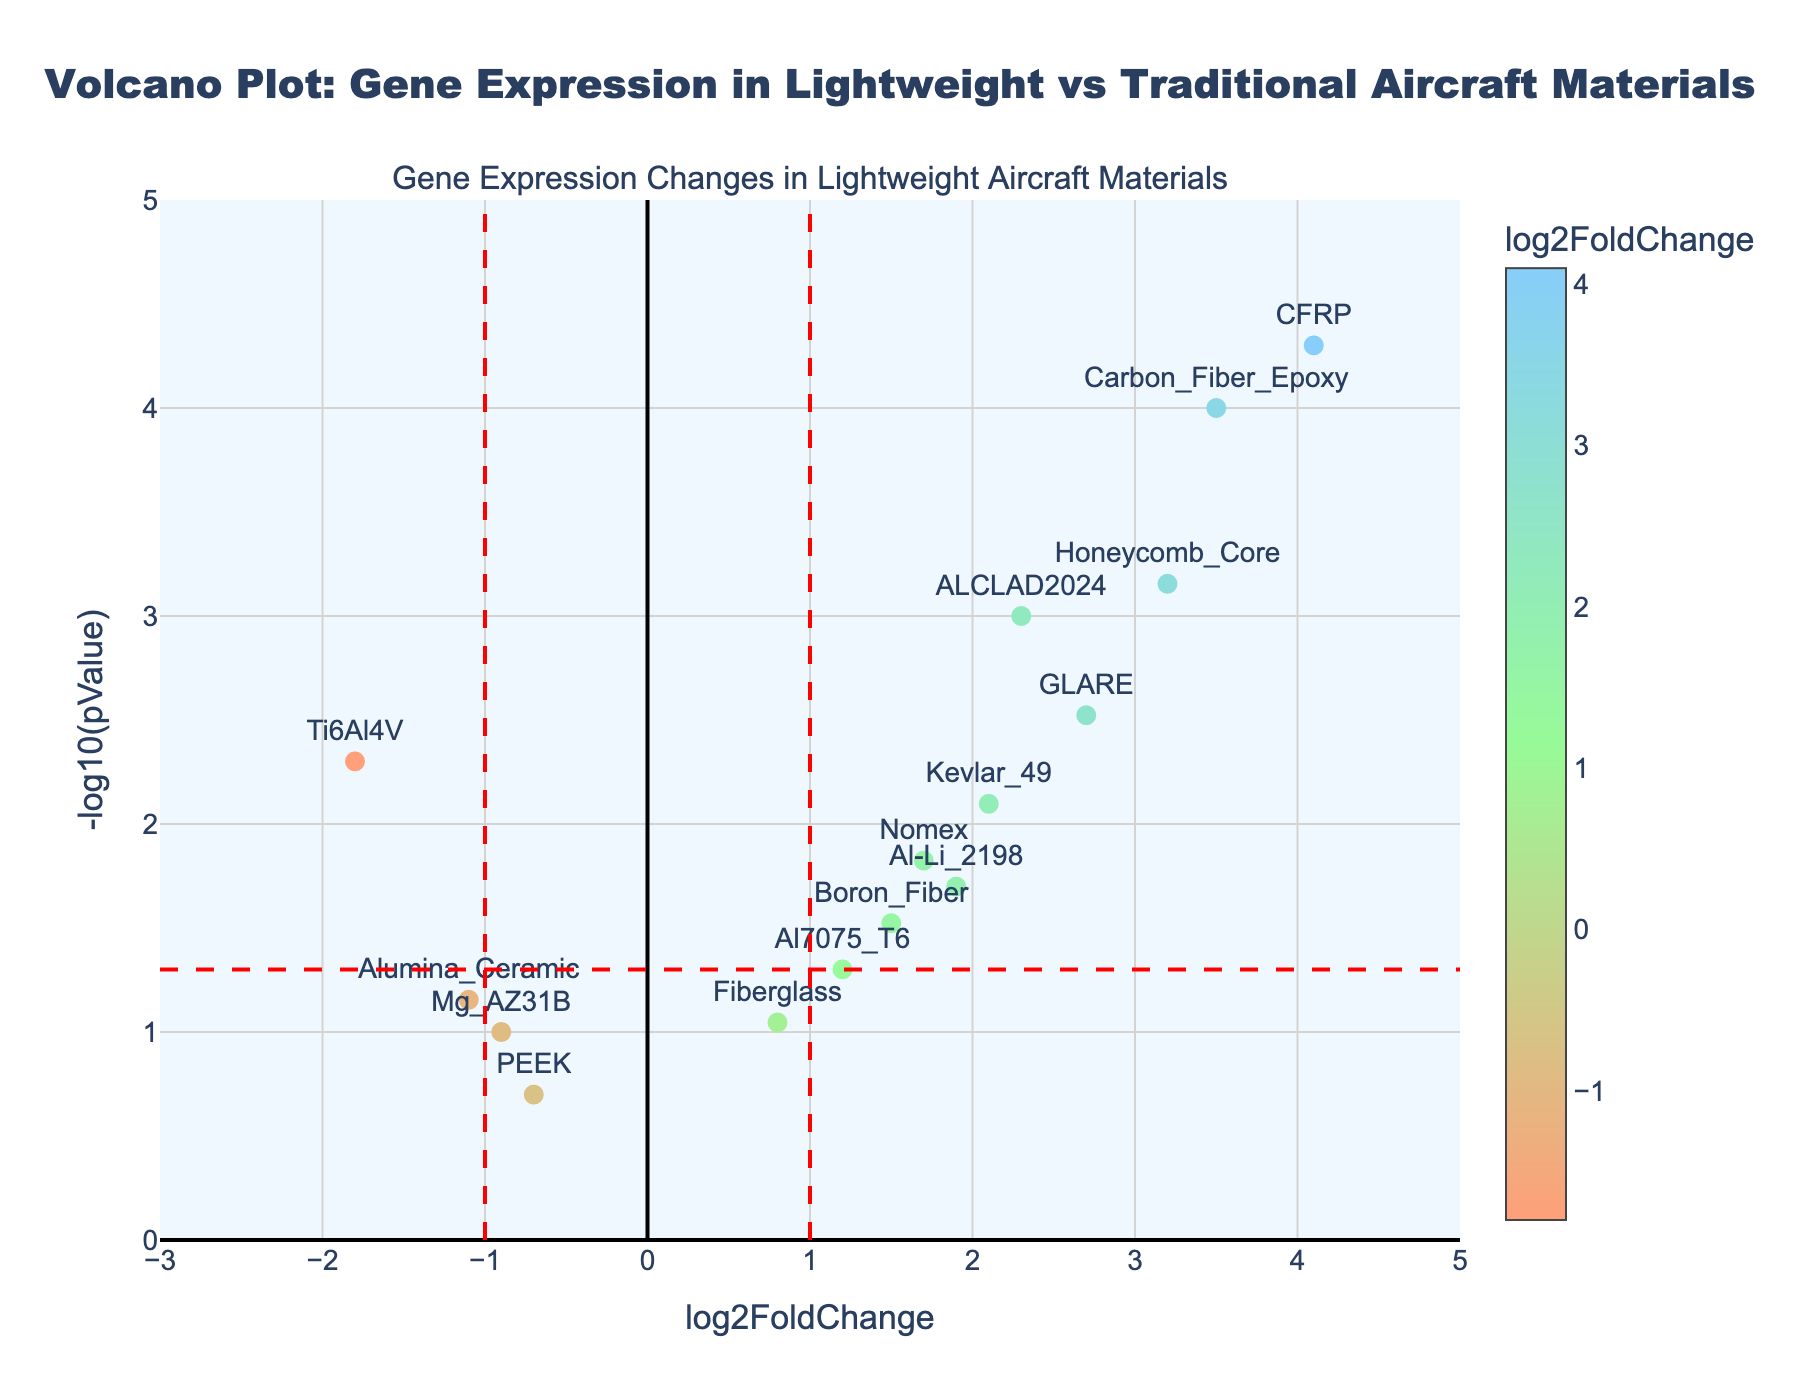What's the title of the plot? The title of the plot is written at the top center of the figure.
Answer: Volcano Plot: Gene Expression in Lightweight vs Traditional Aircraft Materials What are the labels for the x-axis and y-axis? The labels for the x-axis and y-axis can be seen on the respective axes of the plot. The x-axis is labeled 'log2FoldChange' and the y-axis is labeled '-log10(pValue)'.
Answer: log2FoldChange, -log10(pValue) Which data point has the highest log2FoldChange value? By looking at the x-axis values, the data point with the highest log2FoldChange value is labeled 'CFRP' on the positive side.
Answer: CFRP Which data point has the lowest p-value? The lowest p-value corresponds to the highest -log10(pValue). By looking at the maximum y-axis value, the data point 'CFRP' has the lowest p-value.
Answer: CFRP How many threshold lines are shown on the plot? By observing the plot, there are three threshold lines: two vertical lines at log2FoldChange ±1 and one horizontal line at -log10(pValue) = 1.3, indicating a p-value of 0.05.
Answer: 3 Which data points are above the horizontal threshold line of -log10(pValue) = 1.3? Data points above the threshold line of -log10(pValue) = 1.3 are those with significant p-values (p < 0.05). By checking the y-axis, these data points are ALCLAD2024, Ti6Al4V, Carbon_Fiber_Epoxy, GLARE, CFRP, Kevlar_49, Honeycomb_Core, and Nomex.
Answer: ALCLAD2024, Ti6Al4V, Carbon_Fiber_Epoxy, GLARE, CFRP, Kevlar_49, Honeycomb_Core, Nomex Among the data points with a positive log2FoldChange, which has the smallest p-value? Positive log2FoldChange values are to the right of zero on the x-axis. Among these, the smallest p-value corresponds to the maximum y-axis value. The data point 'CFRP' has the smallest p-value.
Answer: CFRP What is the log2FoldChange value for the material 'Boron_Fiber'? By locating the 'Boron_Fiber' text label on the plot and checking its position on the x-axis, the log2FoldChange is approximately 1.5.
Answer: 1.5 What is the p-value for ALCLAD2024? By looking at the ‘ALCLAD2024’ data point, the y-axis value (-log10(pValue)) can be used to get the p-value. The y-axis value is close to 3. This means the p-value is approximately 10^(-3) or 0.001.
Answer: 0.001 